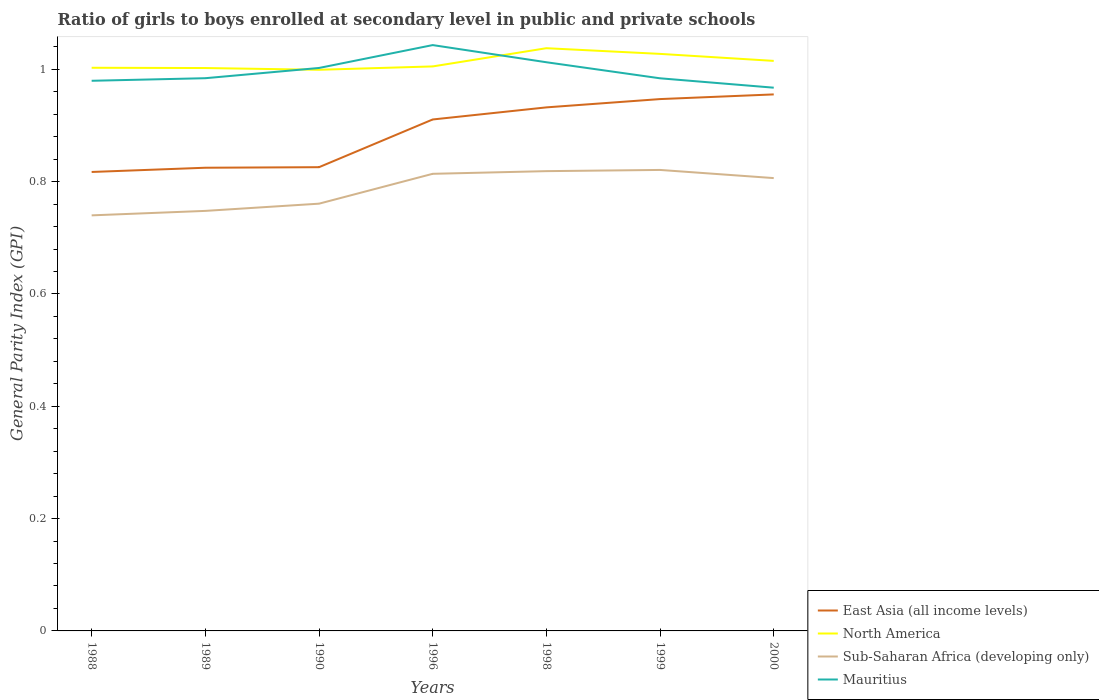How many different coloured lines are there?
Provide a short and direct response. 4. Does the line corresponding to Mauritius intersect with the line corresponding to East Asia (all income levels)?
Provide a succinct answer. No. Is the number of lines equal to the number of legend labels?
Your answer should be very brief. Yes. Across all years, what is the maximum general parity index in Sub-Saharan Africa (developing only)?
Your response must be concise. 0.74. In which year was the general parity index in North America maximum?
Ensure brevity in your answer.  1990. What is the total general parity index in East Asia (all income levels) in the graph?
Make the answer very short. -0.09. What is the difference between the highest and the second highest general parity index in Sub-Saharan Africa (developing only)?
Give a very brief answer. 0.08. What is the difference between the highest and the lowest general parity index in Mauritius?
Keep it short and to the point. 3. Is the general parity index in Sub-Saharan Africa (developing only) strictly greater than the general parity index in Mauritius over the years?
Provide a succinct answer. Yes. How many lines are there?
Your answer should be very brief. 4. What is the difference between two consecutive major ticks on the Y-axis?
Your answer should be compact. 0.2. Does the graph contain any zero values?
Offer a terse response. No. Does the graph contain grids?
Your response must be concise. No. Where does the legend appear in the graph?
Your answer should be compact. Bottom right. How many legend labels are there?
Ensure brevity in your answer.  4. What is the title of the graph?
Your answer should be compact. Ratio of girls to boys enrolled at secondary level in public and private schools. What is the label or title of the Y-axis?
Provide a succinct answer. General Parity Index (GPI). What is the General Parity Index (GPI) in East Asia (all income levels) in 1988?
Offer a terse response. 0.82. What is the General Parity Index (GPI) in North America in 1988?
Offer a terse response. 1. What is the General Parity Index (GPI) of Sub-Saharan Africa (developing only) in 1988?
Give a very brief answer. 0.74. What is the General Parity Index (GPI) of Mauritius in 1988?
Your answer should be very brief. 0.98. What is the General Parity Index (GPI) in East Asia (all income levels) in 1989?
Offer a terse response. 0.82. What is the General Parity Index (GPI) of North America in 1989?
Offer a terse response. 1. What is the General Parity Index (GPI) in Sub-Saharan Africa (developing only) in 1989?
Your answer should be very brief. 0.75. What is the General Parity Index (GPI) of Mauritius in 1989?
Provide a short and direct response. 0.98. What is the General Parity Index (GPI) in East Asia (all income levels) in 1990?
Provide a short and direct response. 0.83. What is the General Parity Index (GPI) of North America in 1990?
Offer a very short reply. 1. What is the General Parity Index (GPI) of Sub-Saharan Africa (developing only) in 1990?
Give a very brief answer. 0.76. What is the General Parity Index (GPI) in Mauritius in 1990?
Make the answer very short. 1. What is the General Parity Index (GPI) in East Asia (all income levels) in 1996?
Ensure brevity in your answer.  0.91. What is the General Parity Index (GPI) of North America in 1996?
Provide a short and direct response. 1.01. What is the General Parity Index (GPI) of Sub-Saharan Africa (developing only) in 1996?
Make the answer very short. 0.81. What is the General Parity Index (GPI) of Mauritius in 1996?
Keep it short and to the point. 1.04. What is the General Parity Index (GPI) in East Asia (all income levels) in 1998?
Keep it short and to the point. 0.93. What is the General Parity Index (GPI) in North America in 1998?
Your answer should be compact. 1.04. What is the General Parity Index (GPI) in Sub-Saharan Africa (developing only) in 1998?
Ensure brevity in your answer.  0.82. What is the General Parity Index (GPI) in Mauritius in 1998?
Your answer should be compact. 1.01. What is the General Parity Index (GPI) in East Asia (all income levels) in 1999?
Ensure brevity in your answer.  0.95. What is the General Parity Index (GPI) of North America in 1999?
Your response must be concise. 1.03. What is the General Parity Index (GPI) of Sub-Saharan Africa (developing only) in 1999?
Your answer should be compact. 0.82. What is the General Parity Index (GPI) in Mauritius in 1999?
Keep it short and to the point. 0.98. What is the General Parity Index (GPI) in East Asia (all income levels) in 2000?
Offer a terse response. 0.96. What is the General Parity Index (GPI) in North America in 2000?
Make the answer very short. 1.02. What is the General Parity Index (GPI) in Sub-Saharan Africa (developing only) in 2000?
Make the answer very short. 0.81. What is the General Parity Index (GPI) in Mauritius in 2000?
Offer a very short reply. 0.97. Across all years, what is the maximum General Parity Index (GPI) of East Asia (all income levels)?
Keep it short and to the point. 0.96. Across all years, what is the maximum General Parity Index (GPI) of North America?
Your response must be concise. 1.04. Across all years, what is the maximum General Parity Index (GPI) in Sub-Saharan Africa (developing only)?
Keep it short and to the point. 0.82. Across all years, what is the maximum General Parity Index (GPI) in Mauritius?
Keep it short and to the point. 1.04. Across all years, what is the minimum General Parity Index (GPI) of East Asia (all income levels)?
Your answer should be very brief. 0.82. Across all years, what is the minimum General Parity Index (GPI) in North America?
Provide a succinct answer. 1. Across all years, what is the minimum General Parity Index (GPI) in Sub-Saharan Africa (developing only)?
Your answer should be very brief. 0.74. Across all years, what is the minimum General Parity Index (GPI) in Mauritius?
Make the answer very short. 0.97. What is the total General Parity Index (GPI) of East Asia (all income levels) in the graph?
Offer a very short reply. 6.21. What is the total General Parity Index (GPI) of North America in the graph?
Your answer should be compact. 7.09. What is the total General Parity Index (GPI) of Sub-Saharan Africa (developing only) in the graph?
Your answer should be very brief. 5.51. What is the total General Parity Index (GPI) in Mauritius in the graph?
Offer a very short reply. 6.97. What is the difference between the General Parity Index (GPI) in East Asia (all income levels) in 1988 and that in 1989?
Keep it short and to the point. -0.01. What is the difference between the General Parity Index (GPI) in Sub-Saharan Africa (developing only) in 1988 and that in 1989?
Offer a very short reply. -0.01. What is the difference between the General Parity Index (GPI) in Mauritius in 1988 and that in 1989?
Make the answer very short. -0. What is the difference between the General Parity Index (GPI) in East Asia (all income levels) in 1988 and that in 1990?
Your response must be concise. -0.01. What is the difference between the General Parity Index (GPI) of North America in 1988 and that in 1990?
Give a very brief answer. 0. What is the difference between the General Parity Index (GPI) in Sub-Saharan Africa (developing only) in 1988 and that in 1990?
Keep it short and to the point. -0.02. What is the difference between the General Parity Index (GPI) in Mauritius in 1988 and that in 1990?
Provide a short and direct response. -0.02. What is the difference between the General Parity Index (GPI) of East Asia (all income levels) in 1988 and that in 1996?
Keep it short and to the point. -0.09. What is the difference between the General Parity Index (GPI) in North America in 1988 and that in 1996?
Keep it short and to the point. -0. What is the difference between the General Parity Index (GPI) of Sub-Saharan Africa (developing only) in 1988 and that in 1996?
Give a very brief answer. -0.07. What is the difference between the General Parity Index (GPI) of Mauritius in 1988 and that in 1996?
Give a very brief answer. -0.06. What is the difference between the General Parity Index (GPI) of East Asia (all income levels) in 1988 and that in 1998?
Your answer should be very brief. -0.12. What is the difference between the General Parity Index (GPI) of North America in 1988 and that in 1998?
Provide a short and direct response. -0.03. What is the difference between the General Parity Index (GPI) in Sub-Saharan Africa (developing only) in 1988 and that in 1998?
Provide a succinct answer. -0.08. What is the difference between the General Parity Index (GPI) in Mauritius in 1988 and that in 1998?
Ensure brevity in your answer.  -0.03. What is the difference between the General Parity Index (GPI) in East Asia (all income levels) in 1988 and that in 1999?
Offer a very short reply. -0.13. What is the difference between the General Parity Index (GPI) of North America in 1988 and that in 1999?
Your answer should be very brief. -0.02. What is the difference between the General Parity Index (GPI) of Sub-Saharan Africa (developing only) in 1988 and that in 1999?
Your response must be concise. -0.08. What is the difference between the General Parity Index (GPI) in Mauritius in 1988 and that in 1999?
Make the answer very short. -0. What is the difference between the General Parity Index (GPI) in East Asia (all income levels) in 1988 and that in 2000?
Offer a terse response. -0.14. What is the difference between the General Parity Index (GPI) in North America in 1988 and that in 2000?
Offer a very short reply. -0.01. What is the difference between the General Parity Index (GPI) of Sub-Saharan Africa (developing only) in 1988 and that in 2000?
Your answer should be compact. -0.07. What is the difference between the General Parity Index (GPI) of Mauritius in 1988 and that in 2000?
Offer a very short reply. 0.01. What is the difference between the General Parity Index (GPI) of East Asia (all income levels) in 1989 and that in 1990?
Ensure brevity in your answer.  -0. What is the difference between the General Parity Index (GPI) of North America in 1989 and that in 1990?
Provide a short and direct response. 0. What is the difference between the General Parity Index (GPI) of Sub-Saharan Africa (developing only) in 1989 and that in 1990?
Keep it short and to the point. -0.01. What is the difference between the General Parity Index (GPI) of Mauritius in 1989 and that in 1990?
Offer a terse response. -0.02. What is the difference between the General Parity Index (GPI) in East Asia (all income levels) in 1989 and that in 1996?
Provide a short and direct response. -0.09. What is the difference between the General Parity Index (GPI) of North America in 1989 and that in 1996?
Ensure brevity in your answer.  -0. What is the difference between the General Parity Index (GPI) in Sub-Saharan Africa (developing only) in 1989 and that in 1996?
Make the answer very short. -0.07. What is the difference between the General Parity Index (GPI) in Mauritius in 1989 and that in 1996?
Provide a short and direct response. -0.06. What is the difference between the General Parity Index (GPI) in East Asia (all income levels) in 1989 and that in 1998?
Your answer should be compact. -0.11. What is the difference between the General Parity Index (GPI) in North America in 1989 and that in 1998?
Ensure brevity in your answer.  -0.04. What is the difference between the General Parity Index (GPI) in Sub-Saharan Africa (developing only) in 1989 and that in 1998?
Offer a terse response. -0.07. What is the difference between the General Parity Index (GPI) of Mauritius in 1989 and that in 1998?
Your response must be concise. -0.03. What is the difference between the General Parity Index (GPI) of East Asia (all income levels) in 1989 and that in 1999?
Your answer should be compact. -0.12. What is the difference between the General Parity Index (GPI) in North America in 1989 and that in 1999?
Your response must be concise. -0.03. What is the difference between the General Parity Index (GPI) in Sub-Saharan Africa (developing only) in 1989 and that in 1999?
Keep it short and to the point. -0.07. What is the difference between the General Parity Index (GPI) of East Asia (all income levels) in 1989 and that in 2000?
Provide a short and direct response. -0.13. What is the difference between the General Parity Index (GPI) in North America in 1989 and that in 2000?
Keep it short and to the point. -0.01. What is the difference between the General Parity Index (GPI) of Sub-Saharan Africa (developing only) in 1989 and that in 2000?
Your response must be concise. -0.06. What is the difference between the General Parity Index (GPI) of Mauritius in 1989 and that in 2000?
Provide a short and direct response. 0.02. What is the difference between the General Parity Index (GPI) in East Asia (all income levels) in 1990 and that in 1996?
Keep it short and to the point. -0.09. What is the difference between the General Parity Index (GPI) of North America in 1990 and that in 1996?
Offer a very short reply. -0.01. What is the difference between the General Parity Index (GPI) of Sub-Saharan Africa (developing only) in 1990 and that in 1996?
Ensure brevity in your answer.  -0.05. What is the difference between the General Parity Index (GPI) of Mauritius in 1990 and that in 1996?
Offer a very short reply. -0.04. What is the difference between the General Parity Index (GPI) in East Asia (all income levels) in 1990 and that in 1998?
Ensure brevity in your answer.  -0.11. What is the difference between the General Parity Index (GPI) in North America in 1990 and that in 1998?
Offer a very short reply. -0.04. What is the difference between the General Parity Index (GPI) of Sub-Saharan Africa (developing only) in 1990 and that in 1998?
Provide a succinct answer. -0.06. What is the difference between the General Parity Index (GPI) in Mauritius in 1990 and that in 1998?
Make the answer very short. -0.01. What is the difference between the General Parity Index (GPI) in East Asia (all income levels) in 1990 and that in 1999?
Make the answer very short. -0.12. What is the difference between the General Parity Index (GPI) of North America in 1990 and that in 1999?
Offer a terse response. -0.03. What is the difference between the General Parity Index (GPI) of Sub-Saharan Africa (developing only) in 1990 and that in 1999?
Offer a very short reply. -0.06. What is the difference between the General Parity Index (GPI) in Mauritius in 1990 and that in 1999?
Provide a short and direct response. 0.02. What is the difference between the General Parity Index (GPI) in East Asia (all income levels) in 1990 and that in 2000?
Your answer should be compact. -0.13. What is the difference between the General Parity Index (GPI) of North America in 1990 and that in 2000?
Ensure brevity in your answer.  -0.02. What is the difference between the General Parity Index (GPI) in Sub-Saharan Africa (developing only) in 1990 and that in 2000?
Ensure brevity in your answer.  -0.05. What is the difference between the General Parity Index (GPI) of Mauritius in 1990 and that in 2000?
Keep it short and to the point. 0.04. What is the difference between the General Parity Index (GPI) of East Asia (all income levels) in 1996 and that in 1998?
Keep it short and to the point. -0.02. What is the difference between the General Parity Index (GPI) of North America in 1996 and that in 1998?
Ensure brevity in your answer.  -0.03. What is the difference between the General Parity Index (GPI) in Sub-Saharan Africa (developing only) in 1996 and that in 1998?
Your answer should be very brief. -0. What is the difference between the General Parity Index (GPI) of Mauritius in 1996 and that in 1998?
Provide a succinct answer. 0.03. What is the difference between the General Parity Index (GPI) in East Asia (all income levels) in 1996 and that in 1999?
Your answer should be compact. -0.04. What is the difference between the General Parity Index (GPI) of North America in 1996 and that in 1999?
Ensure brevity in your answer.  -0.02. What is the difference between the General Parity Index (GPI) in Sub-Saharan Africa (developing only) in 1996 and that in 1999?
Provide a short and direct response. -0.01. What is the difference between the General Parity Index (GPI) of Mauritius in 1996 and that in 1999?
Your answer should be very brief. 0.06. What is the difference between the General Parity Index (GPI) of East Asia (all income levels) in 1996 and that in 2000?
Make the answer very short. -0.04. What is the difference between the General Parity Index (GPI) in North America in 1996 and that in 2000?
Make the answer very short. -0.01. What is the difference between the General Parity Index (GPI) of Sub-Saharan Africa (developing only) in 1996 and that in 2000?
Give a very brief answer. 0.01. What is the difference between the General Parity Index (GPI) in Mauritius in 1996 and that in 2000?
Ensure brevity in your answer.  0.08. What is the difference between the General Parity Index (GPI) in East Asia (all income levels) in 1998 and that in 1999?
Your answer should be compact. -0.01. What is the difference between the General Parity Index (GPI) in North America in 1998 and that in 1999?
Your response must be concise. 0.01. What is the difference between the General Parity Index (GPI) of Sub-Saharan Africa (developing only) in 1998 and that in 1999?
Your response must be concise. -0. What is the difference between the General Parity Index (GPI) of Mauritius in 1998 and that in 1999?
Your answer should be compact. 0.03. What is the difference between the General Parity Index (GPI) of East Asia (all income levels) in 1998 and that in 2000?
Make the answer very short. -0.02. What is the difference between the General Parity Index (GPI) of North America in 1998 and that in 2000?
Keep it short and to the point. 0.02. What is the difference between the General Parity Index (GPI) of Sub-Saharan Africa (developing only) in 1998 and that in 2000?
Give a very brief answer. 0.01. What is the difference between the General Parity Index (GPI) of Mauritius in 1998 and that in 2000?
Offer a very short reply. 0.05. What is the difference between the General Parity Index (GPI) in East Asia (all income levels) in 1999 and that in 2000?
Your answer should be very brief. -0.01. What is the difference between the General Parity Index (GPI) of North America in 1999 and that in 2000?
Give a very brief answer. 0.01. What is the difference between the General Parity Index (GPI) of Sub-Saharan Africa (developing only) in 1999 and that in 2000?
Ensure brevity in your answer.  0.01. What is the difference between the General Parity Index (GPI) of Mauritius in 1999 and that in 2000?
Ensure brevity in your answer.  0.02. What is the difference between the General Parity Index (GPI) in East Asia (all income levels) in 1988 and the General Parity Index (GPI) in North America in 1989?
Keep it short and to the point. -0.19. What is the difference between the General Parity Index (GPI) of East Asia (all income levels) in 1988 and the General Parity Index (GPI) of Sub-Saharan Africa (developing only) in 1989?
Keep it short and to the point. 0.07. What is the difference between the General Parity Index (GPI) in East Asia (all income levels) in 1988 and the General Parity Index (GPI) in Mauritius in 1989?
Provide a short and direct response. -0.17. What is the difference between the General Parity Index (GPI) in North America in 1988 and the General Parity Index (GPI) in Sub-Saharan Africa (developing only) in 1989?
Provide a succinct answer. 0.25. What is the difference between the General Parity Index (GPI) in North America in 1988 and the General Parity Index (GPI) in Mauritius in 1989?
Your response must be concise. 0.02. What is the difference between the General Parity Index (GPI) of Sub-Saharan Africa (developing only) in 1988 and the General Parity Index (GPI) of Mauritius in 1989?
Keep it short and to the point. -0.24. What is the difference between the General Parity Index (GPI) in East Asia (all income levels) in 1988 and the General Parity Index (GPI) in North America in 1990?
Make the answer very short. -0.18. What is the difference between the General Parity Index (GPI) of East Asia (all income levels) in 1988 and the General Parity Index (GPI) of Sub-Saharan Africa (developing only) in 1990?
Provide a succinct answer. 0.06. What is the difference between the General Parity Index (GPI) of East Asia (all income levels) in 1988 and the General Parity Index (GPI) of Mauritius in 1990?
Keep it short and to the point. -0.19. What is the difference between the General Parity Index (GPI) of North America in 1988 and the General Parity Index (GPI) of Sub-Saharan Africa (developing only) in 1990?
Provide a succinct answer. 0.24. What is the difference between the General Parity Index (GPI) of Sub-Saharan Africa (developing only) in 1988 and the General Parity Index (GPI) of Mauritius in 1990?
Keep it short and to the point. -0.26. What is the difference between the General Parity Index (GPI) of East Asia (all income levels) in 1988 and the General Parity Index (GPI) of North America in 1996?
Give a very brief answer. -0.19. What is the difference between the General Parity Index (GPI) of East Asia (all income levels) in 1988 and the General Parity Index (GPI) of Sub-Saharan Africa (developing only) in 1996?
Your response must be concise. 0. What is the difference between the General Parity Index (GPI) of East Asia (all income levels) in 1988 and the General Parity Index (GPI) of Mauritius in 1996?
Your answer should be very brief. -0.23. What is the difference between the General Parity Index (GPI) in North America in 1988 and the General Parity Index (GPI) in Sub-Saharan Africa (developing only) in 1996?
Your response must be concise. 0.19. What is the difference between the General Parity Index (GPI) of North America in 1988 and the General Parity Index (GPI) of Mauritius in 1996?
Ensure brevity in your answer.  -0.04. What is the difference between the General Parity Index (GPI) of Sub-Saharan Africa (developing only) in 1988 and the General Parity Index (GPI) of Mauritius in 1996?
Your answer should be compact. -0.3. What is the difference between the General Parity Index (GPI) in East Asia (all income levels) in 1988 and the General Parity Index (GPI) in North America in 1998?
Your answer should be very brief. -0.22. What is the difference between the General Parity Index (GPI) in East Asia (all income levels) in 1988 and the General Parity Index (GPI) in Sub-Saharan Africa (developing only) in 1998?
Provide a short and direct response. -0. What is the difference between the General Parity Index (GPI) of East Asia (all income levels) in 1988 and the General Parity Index (GPI) of Mauritius in 1998?
Keep it short and to the point. -0.2. What is the difference between the General Parity Index (GPI) of North America in 1988 and the General Parity Index (GPI) of Sub-Saharan Africa (developing only) in 1998?
Provide a short and direct response. 0.18. What is the difference between the General Parity Index (GPI) in North America in 1988 and the General Parity Index (GPI) in Mauritius in 1998?
Offer a very short reply. -0.01. What is the difference between the General Parity Index (GPI) of Sub-Saharan Africa (developing only) in 1988 and the General Parity Index (GPI) of Mauritius in 1998?
Your answer should be compact. -0.27. What is the difference between the General Parity Index (GPI) of East Asia (all income levels) in 1988 and the General Parity Index (GPI) of North America in 1999?
Provide a succinct answer. -0.21. What is the difference between the General Parity Index (GPI) in East Asia (all income levels) in 1988 and the General Parity Index (GPI) in Sub-Saharan Africa (developing only) in 1999?
Provide a succinct answer. -0. What is the difference between the General Parity Index (GPI) of East Asia (all income levels) in 1988 and the General Parity Index (GPI) of Mauritius in 1999?
Give a very brief answer. -0.17. What is the difference between the General Parity Index (GPI) in North America in 1988 and the General Parity Index (GPI) in Sub-Saharan Africa (developing only) in 1999?
Ensure brevity in your answer.  0.18. What is the difference between the General Parity Index (GPI) in North America in 1988 and the General Parity Index (GPI) in Mauritius in 1999?
Offer a terse response. 0.02. What is the difference between the General Parity Index (GPI) in Sub-Saharan Africa (developing only) in 1988 and the General Parity Index (GPI) in Mauritius in 1999?
Ensure brevity in your answer.  -0.24. What is the difference between the General Parity Index (GPI) of East Asia (all income levels) in 1988 and the General Parity Index (GPI) of North America in 2000?
Give a very brief answer. -0.2. What is the difference between the General Parity Index (GPI) of East Asia (all income levels) in 1988 and the General Parity Index (GPI) of Sub-Saharan Africa (developing only) in 2000?
Your answer should be very brief. 0.01. What is the difference between the General Parity Index (GPI) of East Asia (all income levels) in 1988 and the General Parity Index (GPI) of Mauritius in 2000?
Offer a terse response. -0.15. What is the difference between the General Parity Index (GPI) of North America in 1988 and the General Parity Index (GPI) of Sub-Saharan Africa (developing only) in 2000?
Ensure brevity in your answer.  0.2. What is the difference between the General Parity Index (GPI) of North America in 1988 and the General Parity Index (GPI) of Mauritius in 2000?
Provide a short and direct response. 0.04. What is the difference between the General Parity Index (GPI) in Sub-Saharan Africa (developing only) in 1988 and the General Parity Index (GPI) in Mauritius in 2000?
Provide a succinct answer. -0.23. What is the difference between the General Parity Index (GPI) in East Asia (all income levels) in 1989 and the General Parity Index (GPI) in North America in 1990?
Ensure brevity in your answer.  -0.17. What is the difference between the General Parity Index (GPI) of East Asia (all income levels) in 1989 and the General Parity Index (GPI) of Sub-Saharan Africa (developing only) in 1990?
Provide a succinct answer. 0.06. What is the difference between the General Parity Index (GPI) of East Asia (all income levels) in 1989 and the General Parity Index (GPI) of Mauritius in 1990?
Keep it short and to the point. -0.18. What is the difference between the General Parity Index (GPI) in North America in 1989 and the General Parity Index (GPI) in Sub-Saharan Africa (developing only) in 1990?
Your response must be concise. 0.24. What is the difference between the General Parity Index (GPI) of North America in 1989 and the General Parity Index (GPI) of Mauritius in 1990?
Your response must be concise. -0. What is the difference between the General Parity Index (GPI) in Sub-Saharan Africa (developing only) in 1989 and the General Parity Index (GPI) in Mauritius in 1990?
Provide a succinct answer. -0.25. What is the difference between the General Parity Index (GPI) in East Asia (all income levels) in 1989 and the General Parity Index (GPI) in North America in 1996?
Your response must be concise. -0.18. What is the difference between the General Parity Index (GPI) in East Asia (all income levels) in 1989 and the General Parity Index (GPI) in Sub-Saharan Africa (developing only) in 1996?
Make the answer very short. 0.01. What is the difference between the General Parity Index (GPI) of East Asia (all income levels) in 1989 and the General Parity Index (GPI) of Mauritius in 1996?
Provide a succinct answer. -0.22. What is the difference between the General Parity Index (GPI) of North America in 1989 and the General Parity Index (GPI) of Sub-Saharan Africa (developing only) in 1996?
Your answer should be very brief. 0.19. What is the difference between the General Parity Index (GPI) in North America in 1989 and the General Parity Index (GPI) in Mauritius in 1996?
Your answer should be compact. -0.04. What is the difference between the General Parity Index (GPI) of Sub-Saharan Africa (developing only) in 1989 and the General Parity Index (GPI) of Mauritius in 1996?
Ensure brevity in your answer.  -0.3. What is the difference between the General Parity Index (GPI) in East Asia (all income levels) in 1989 and the General Parity Index (GPI) in North America in 1998?
Offer a very short reply. -0.21. What is the difference between the General Parity Index (GPI) of East Asia (all income levels) in 1989 and the General Parity Index (GPI) of Sub-Saharan Africa (developing only) in 1998?
Keep it short and to the point. 0.01. What is the difference between the General Parity Index (GPI) in East Asia (all income levels) in 1989 and the General Parity Index (GPI) in Mauritius in 1998?
Your answer should be very brief. -0.19. What is the difference between the General Parity Index (GPI) in North America in 1989 and the General Parity Index (GPI) in Sub-Saharan Africa (developing only) in 1998?
Your answer should be very brief. 0.18. What is the difference between the General Parity Index (GPI) of North America in 1989 and the General Parity Index (GPI) of Mauritius in 1998?
Your answer should be very brief. -0.01. What is the difference between the General Parity Index (GPI) of Sub-Saharan Africa (developing only) in 1989 and the General Parity Index (GPI) of Mauritius in 1998?
Your response must be concise. -0.26. What is the difference between the General Parity Index (GPI) in East Asia (all income levels) in 1989 and the General Parity Index (GPI) in North America in 1999?
Your response must be concise. -0.2. What is the difference between the General Parity Index (GPI) in East Asia (all income levels) in 1989 and the General Parity Index (GPI) in Sub-Saharan Africa (developing only) in 1999?
Your answer should be compact. 0. What is the difference between the General Parity Index (GPI) of East Asia (all income levels) in 1989 and the General Parity Index (GPI) of Mauritius in 1999?
Offer a terse response. -0.16. What is the difference between the General Parity Index (GPI) in North America in 1989 and the General Parity Index (GPI) in Sub-Saharan Africa (developing only) in 1999?
Your answer should be very brief. 0.18. What is the difference between the General Parity Index (GPI) of North America in 1989 and the General Parity Index (GPI) of Mauritius in 1999?
Provide a short and direct response. 0.02. What is the difference between the General Parity Index (GPI) in Sub-Saharan Africa (developing only) in 1989 and the General Parity Index (GPI) in Mauritius in 1999?
Make the answer very short. -0.24. What is the difference between the General Parity Index (GPI) in East Asia (all income levels) in 1989 and the General Parity Index (GPI) in North America in 2000?
Make the answer very short. -0.19. What is the difference between the General Parity Index (GPI) of East Asia (all income levels) in 1989 and the General Parity Index (GPI) of Sub-Saharan Africa (developing only) in 2000?
Your answer should be compact. 0.02. What is the difference between the General Parity Index (GPI) in East Asia (all income levels) in 1989 and the General Parity Index (GPI) in Mauritius in 2000?
Your answer should be very brief. -0.14. What is the difference between the General Parity Index (GPI) in North America in 1989 and the General Parity Index (GPI) in Sub-Saharan Africa (developing only) in 2000?
Provide a short and direct response. 0.2. What is the difference between the General Parity Index (GPI) in North America in 1989 and the General Parity Index (GPI) in Mauritius in 2000?
Your response must be concise. 0.04. What is the difference between the General Parity Index (GPI) in Sub-Saharan Africa (developing only) in 1989 and the General Parity Index (GPI) in Mauritius in 2000?
Make the answer very short. -0.22. What is the difference between the General Parity Index (GPI) of East Asia (all income levels) in 1990 and the General Parity Index (GPI) of North America in 1996?
Provide a succinct answer. -0.18. What is the difference between the General Parity Index (GPI) of East Asia (all income levels) in 1990 and the General Parity Index (GPI) of Sub-Saharan Africa (developing only) in 1996?
Offer a very short reply. 0.01. What is the difference between the General Parity Index (GPI) in East Asia (all income levels) in 1990 and the General Parity Index (GPI) in Mauritius in 1996?
Offer a very short reply. -0.22. What is the difference between the General Parity Index (GPI) in North America in 1990 and the General Parity Index (GPI) in Sub-Saharan Africa (developing only) in 1996?
Your answer should be compact. 0.19. What is the difference between the General Parity Index (GPI) of North America in 1990 and the General Parity Index (GPI) of Mauritius in 1996?
Provide a short and direct response. -0.04. What is the difference between the General Parity Index (GPI) of Sub-Saharan Africa (developing only) in 1990 and the General Parity Index (GPI) of Mauritius in 1996?
Offer a terse response. -0.28. What is the difference between the General Parity Index (GPI) of East Asia (all income levels) in 1990 and the General Parity Index (GPI) of North America in 1998?
Your answer should be very brief. -0.21. What is the difference between the General Parity Index (GPI) in East Asia (all income levels) in 1990 and the General Parity Index (GPI) in Sub-Saharan Africa (developing only) in 1998?
Your answer should be very brief. 0.01. What is the difference between the General Parity Index (GPI) of East Asia (all income levels) in 1990 and the General Parity Index (GPI) of Mauritius in 1998?
Provide a short and direct response. -0.19. What is the difference between the General Parity Index (GPI) of North America in 1990 and the General Parity Index (GPI) of Sub-Saharan Africa (developing only) in 1998?
Ensure brevity in your answer.  0.18. What is the difference between the General Parity Index (GPI) in North America in 1990 and the General Parity Index (GPI) in Mauritius in 1998?
Keep it short and to the point. -0.01. What is the difference between the General Parity Index (GPI) of Sub-Saharan Africa (developing only) in 1990 and the General Parity Index (GPI) of Mauritius in 1998?
Offer a very short reply. -0.25. What is the difference between the General Parity Index (GPI) in East Asia (all income levels) in 1990 and the General Parity Index (GPI) in North America in 1999?
Your response must be concise. -0.2. What is the difference between the General Parity Index (GPI) of East Asia (all income levels) in 1990 and the General Parity Index (GPI) of Sub-Saharan Africa (developing only) in 1999?
Keep it short and to the point. 0. What is the difference between the General Parity Index (GPI) in East Asia (all income levels) in 1990 and the General Parity Index (GPI) in Mauritius in 1999?
Give a very brief answer. -0.16. What is the difference between the General Parity Index (GPI) in North America in 1990 and the General Parity Index (GPI) in Sub-Saharan Africa (developing only) in 1999?
Provide a short and direct response. 0.18. What is the difference between the General Parity Index (GPI) in North America in 1990 and the General Parity Index (GPI) in Mauritius in 1999?
Ensure brevity in your answer.  0.02. What is the difference between the General Parity Index (GPI) in Sub-Saharan Africa (developing only) in 1990 and the General Parity Index (GPI) in Mauritius in 1999?
Your answer should be very brief. -0.22. What is the difference between the General Parity Index (GPI) in East Asia (all income levels) in 1990 and the General Parity Index (GPI) in North America in 2000?
Provide a succinct answer. -0.19. What is the difference between the General Parity Index (GPI) in East Asia (all income levels) in 1990 and the General Parity Index (GPI) in Sub-Saharan Africa (developing only) in 2000?
Your answer should be very brief. 0.02. What is the difference between the General Parity Index (GPI) in East Asia (all income levels) in 1990 and the General Parity Index (GPI) in Mauritius in 2000?
Ensure brevity in your answer.  -0.14. What is the difference between the General Parity Index (GPI) of North America in 1990 and the General Parity Index (GPI) of Sub-Saharan Africa (developing only) in 2000?
Offer a very short reply. 0.19. What is the difference between the General Parity Index (GPI) in North America in 1990 and the General Parity Index (GPI) in Mauritius in 2000?
Make the answer very short. 0.03. What is the difference between the General Parity Index (GPI) in Sub-Saharan Africa (developing only) in 1990 and the General Parity Index (GPI) in Mauritius in 2000?
Keep it short and to the point. -0.21. What is the difference between the General Parity Index (GPI) of East Asia (all income levels) in 1996 and the General Parity Index (GPI) of North America in 1998?
Ensure brevity in your answer.  -0.13. What is the difference between the General Parity Index (GPI) of East Asia (all income levels) in 1996 and the General Parity Index (GPI) of Sub-Saharan Africa (developing only) in 1998?
Make the answer very short. 0.09. What is the difference between the General Parity Index (GPI) in East Asia (all income levels) in 1996 and the General Parity Index (GPI) in Mauritius in 1998?
Your answer should be compact. -0.1. What is the difference between the General Parity Index (GPI) in North America in 1996 and the General Parity Index (GPI) in Sub-Saharan Africa (developing only) in 1998?
Provide a short and direct response. 0.19. What is the difference between the General Parity Index (GPI) in North America in 1996 and the General Parity Index (GPI) in Mauritius in 1998?
Make the answer very short. -0.01. What is the difference between the General Parity Index (GPI) in Sub-Saharan Africa (developing only) in 1996 and the General Parity Index (GPI) in Mauritius in 1998?
Your response must be concise. -0.2. What is the difference between the General Parity Index (GPI) of East Asia (all income levels) in 1996 and the General Parity Index (GPI) of North America in 1999?
Your response must be concise. -0.12. What is the difference between the General Parity Index (GPI) in East Asia (all income levels) in 1996 and the General Parity Index (GPI) in Sub-Saharan Africa (developing only) in 1999?
Your answer should be compact. 0.09. What is the difference between the General Parity Index (GPI) of East Asia (all income levels) in 1996 and the General Parity Index (GPI) of Mauritius in 1999?
Provide a succinct answer. -0.07. What is the difference between the General Parity Index (GPI) in North America in 1996 and the General Parity Index (GPI) in Sub-Saharan Africa (developing only) in 1999?
Give a very brief answer. 0.18. What is the difference between the General Parity Index (GPI) in North America in 1996 and the General Parity Index (GPI) in Mauritius in 1999?
Your answer should be very brief. 0.02. What is the difference between the General Parity Index (GPI) of Sub-Saharan Africa (developing only) in 1996 and the General Parity Index (GPI) of Mauritius in 1999?
Your response must be concise. -0.17. What is the difference between the General Parity Index (GPI) of East Asia (all income levels) in 1996 and the General Parity Index (GPI) of North America in 2000?
Ensure brevity in your answer.  -0.1. What is the difference between the General Parity Index (GPI) in East Asia (all income levels) in 1996 and the General Parity Index (GPI) in Sub-Saharan Africa (developing only) in 2000?
Provide a succinct answer. 0.1. What is the difference between the General Parity Index (GPI) in East Asia (all income levels) in 1996 and the General Parity Index (GPI) in Mauritius in 2000?
Your response must be concise. -0.06. What is the difference between the General Parity Index (GPI) of North America in 1996 and the General Parity Index (GPI) of Sub-Saharan Africa (developing only) in 2000?
Offer a very short reply. 0.2. What is the difference between the General Parity Index (GPI) in North America in 1996 and the General Parity Index (GPI) in Mauritius in 2000?
Your answer should be compact. 0.04. What is the difference between the General Parity Index (GPI) in Sub-Saharan Africa (developing only) in 1996 and the General Parity Index (GPI) in Mauritius in 2000?
Ensure brevity in your answer.  -0.15. What is the difference between the General Parity Index (GPI) of East Asia (all income levels) in 1998 and the General Parity Index (GPI) of North America in 1999?
Your response must be concise. -0.1. What is the difference between the General Parity Index (GPI) in East Asia (all income levels) in 1998 and the General Parity Index (GPI) in Sub-Saharan Africa (developing only) in 1999?
Your response must be concise. 0.11. What is the difference between the General Parity Index (GPI) of East Asia (all income levels) in 1998 and the General Parity Index (GPI) of Mauritius in 1999?
Offer a terse response. -0.05. What is the difference between the General Parity Index (GPI) of North America in 1998 and the General Parity Index (GPI) of Sub-Saharan Africa (developing only) in 1999?
Provide a succinct answer. 0.22. What is the difference between the General Parity Index (GPI) in North America in 1998 and the General Parity Index (GPI) in Mauritius in 1999?
Keep it short and to the point. 0.05. What is the difference between the General Parity Index (GPI) of Sub-Saharan Africa (developing only) in 1998 and the General Parity Index (GPI) of Mauritius in 1999?
Keep it short and to the point. -0.17. What is the difference between the General Parity Index (GPI) in East Asia (all income levels) in 1998 and the General Parity Index (GPI) in North America in 2000?
Provide a short and direct response. -0.08. What is the difference between the General Parity Index (GPI) in East Asia (all income levels) in 1998 and the General Parity Index (GPI) in Sub-Saharan Africa (developing only) in 2000?
Ensure brevity in your answer.  0.13. What is the difference between the General Parity Index (GPI) in East Asia (all income levels) in 1998 and the General Parity Index (GPI) in Mauritius in 2000?
Your response must be concise. -0.04. What is the difference between the General Parity Index (GPI) in North America in 1998 and the General Parity Index (GPI) in Sub-Saharan Africa (developing only) in 2000?
Your answer should be compact. 0.23. What is the difference between the General Parity Index (GPI) in North America in 1998 and the General Parity Index (GPI) in Mauritius in 2000?
Give a very brief answer. 0.07. What is the difference between the General Parity Index (GPI) in Sub-Saharan Africa (developing only) in 1998 and the General Parity Index (GPI) in Mauritius in 2000?
Your answer should be very brief. -0.15. What is the difference between the General Parity Index (GPI) of East Asia (all income levels) in 1999 and the General Parity Index (GPI) of North America in 2000?
Keep it short and to the point. -0.07. What is the difference between the General Parity Index (GPI) of East Asia (all income levels) in 1999 and the General Parity Index (GPI) of Sub-Saharan Africa (developing only) in 2000?
Ensure brevity in your answer.  0.14. What is the difference between the General Parity Index (GPI) of East Asia (all income levels) in 1999 and the General Parity Index (GPI) of Mauritius in 2000?
Provide a succinct answer. -0.02. What is the difference between the General Parity Index (GPI) in North America in 1999 and the General Parity Index (GPI) in Sub-Saharan Africa (developing only) in 2000?
Your answer should be very brief. 0.22. What is the difference between the General Parity Index (GPI) of North America in 1999 and the General Parity Index (GPI) of Mauritius in 2000?
Give a very brief answer. 0.06. What is the difference between the General Parity Index (GPI) of Sub-Saharan Africa (developing only) in 1999 and the General Parity Index (GPI) of Mauritius in 2000?
Keep it short and to the point. -0.15. What is the average General Parity Index (GPI) of East Asia (all income levels) per year?
Your answer should be very brief. 0.89. What is the average General Parity Index (GPI) in North America per year?
Your answer should be compact. 1.01. What is the average General Parity Index (GPI) of Sub-Saharan Africa (developing only) per year?
Provide a short and direct response. 0.79. What is the average General Parity Index (GPI) in Mauritius per year?
Ensure brevity in your answer.  1. In the year 1988, what is the difference between the General Parity Index (GPI) in East Asia (all income levels) and General Parity Index (GPI) in North America?
Offer a very short reply. -0.19. In the year 1988, what is the difference between the General Parity Index (GPI) of East Asia (all income levels) and General Parity Index (GPI) of Sub-Saharan Africa (developing only)?
Your answer should be very brief. 0.08. In the year 1988, what is the difference between the General Parity Index (GPI) of East Asia (all income levels) and General Parity Index (GPI) of Mauritius?
Provide a succinct answer. -0.16. In the year 1988, what is the difference between the General Parity Index (GPI) of North America and General Parity Index (GPI) of Sub-Saharan Africa (developing only)?
Provide a succinct answer. 0.26. In the year 1988, what is the difference between the General Parity Index (GPI) in North America and General Parity Index (GPI) in Mauritius?
Your answer should be very brief. 0.02. In the year 1988, what is the difference between the General Parity Index (GPI) of Sub-Saharan Africa (developing only) and General Parity Index (GPI) of Mauritius?
Give a very brief answer. -0.24. In the year 1989, what is the difference between the General Parity Index (GPI) of East Asia (all income levels) and General Parity Index (GPI) of North America?
Ensure brevity in your answer.  -0.18. In the year 1989, what is the difference between the General Parity Index (GPI) in East Asia (all income levels) and General Parity Index (GPI) in Sub-Saharan Africa (developing only)?
Provide a short and direct response. 0.08. In the year 1989, what is the difference between the General Parity Index (GPI) in East Asia (all income levels) and General Parity Index (GPI) in Mauritius?
Your response must be concise. -0.16. In the year 1989, what is the difference between the General Parity Index (GPI) of North America and General Parity Index (GPI) of Sub-Saharan Africa (developing only)?
Give a very brief answer. 0.25. In the year 1989, what is the difference between the General Parity Index (GPI) in North America and General Parity Index (GPI) in Mauritius?
Provide a short and direct response. 0.02. In the year 1989, what is the difference between the General Parity Index (GPI) in Sub-Saharan Africa (developing only) and General Parity Index (GPI) in Mauritius?
Your answer should be very brief. -0.24. In the year 1990, what is the difference between the General Parity Index (GPI) of East Asia (all income levels) and General Parity Index (GPI) of North America?
Ensure brevity in your answer.  -0.17. In the year 1990, what is the difference between the General Parity Index (GPI) in East Asia (all income levels) and General Parity Index (GPI) in Sub-Saharan Africa (developing only)?
Give a very brief answer. 0.07. In the year 1990, what is the difference between the General Parity Index (GPI) of East Asia (all income levels) and General Parity Index (GPI) of Mauritius?
Your answer should be compact. -0.18. In the year 1990, what is the difference between the General Parity Index (GPI) of North America and General Parity Index (GPI) of Sub-Saharan Africa (developing only)?
Offer a very short reply. 0.24. In the year 1990, what is the difference between the General Parity Index (GPI) of North America and General Parity Index (GPI) of Mauritius?
Your answer should be compact. -0. In the year 1990, what is the difference between the General Parity Index (GPI) in Sub-Saharan Africa (developing only) and General Parity Index (GPI) in Mauritius?
Your answer should be very brief. -0.24. In the year 1996, what is the difference between the General Parity Index (GPI) of East Asia (all income levels) and General Parity Index (GPI) of North America?
Provide a succinct answer. -0.09. In the year 1996, what is the difference between the General Parity Index (GPI) of East Asia (all income levels) and General Parity Index (GPI) of Sub-Saharan Africa (developing only)?
Your answer should be very brief. 0.1. In the year 1996, what is the difference between the General Parity Index (GPI) in East Asia (all income levels) and General Parity Index (GPI) in Mauritius?
Provide a short and direct response. -0.13. In the year 1996, what is the difference between the General Parity Index (GPI) of North America and General Parity Index (GPI) of Sub-Saharan Africa (developing only)?
Keep it short and to the point. 0.19. In the year 1996, what is the difference between the General Parity Index (GPI) in North America and General Parity Index (GPI) in Mauritius?
Ensure brevity in your answer.  -0.04. In the year 1996, what is the difference between the General Parity Index (GPI) in Sub-Saharan Africa (developing only) and General Parity Index (GPI) in Mauritius?
Ensure brevity in your answer.  -0.23. In the year 1998, what is the difference between the General Parity Index (GPI) of East Asia (all income levels) and General Parity Index (GPI) of North America?
Your answer should be very brief. -0.11. In the year 1998, what is the difference between the General Parity Index (GPI) of East Asia (all income levels) and General Parity Index (GPI) of Sub-Saharan Africa (developing only)?
Offer a terse response. 0.11. In the year 1998, what is the difference between the General Parity Index (GPI) in East Asia (all income levels) and General Parity Index (GPI) in Mauritius?
Make the answer very short. -0.08. In the year 1998, what is the difference between the General Parity Index (GPI) in North America and General Parity Index (GPI) in Sub-Saharan Africa (developing only)?
Your answer should be compact. 0.22. In the year 1998, what is the difference between the General Parity Index (GPI) of North America and General Parity Index (GPI) of Mauritius?
Your answer should be compact. 0.03. In the year 1998, what is the difference between the General Parity Index (GPI) in Sub-Saharan Africa (developing only) and General Parity Index (GPI) in Mauritius?
Your response must be concise. -0.19. In the year 1999, what is the difference between the General Parity Index (GPI) in East Asia (all income levels) and General Parity Index (GPI) in North America?
Ensure brevity in your answer.  -0.08. In the year 1999, what is the difference between the General Parity Index (GPI) of East Asia (all income levels) and General Parity Index (GPI) of Sub-Saharan Africa (developing only)?
Offer a terse response. 0.13. In the year 1999, what is the difference between the General Parity Index (GPI) in East Asia (all income levels) and General Parity Index (GPI) in Mauritius?
Make the answer very short. -0.04. In the year 1999, what is the difference between the General Parity Index (GPI) in North America and General Parity Index (GPI) in Sub-Saharan Africa (developing only)?
Ensure brevity in your answer.  0.21. In the year 1999, what is the difference between the General Parity Index (GPI) in North America and General Parity Index (GPI) in Mauritius?
Provide a short and direct response. 0.04. In the year 1999, what is the difference between the General Parity Index (GPI) in Sub-Saharan Africa (developing only) and General Parity Index (GPI) in Mauritius?
Provide a short and direct response. -0.16. In the year 2000, what is the difference between the General Parity Index (GPI) in East Asia (all income levels) and General Parity Index (GPI) in North America?
Your answer should be compact. -0.06. In the year 2000, what is the difference between the General Parity Index (GPI) of East Asia (all income levels) and General Parity Index (GPI) of Sub-Saharan Africa (developing only)?
Offer a very short reply. 0.15. In the year 2000, what is the difference between the General Parity Index (GPI) of East Asia (all income levels) and General Parity Index (GPI) of Mauritius?
Provide a succinct answer. -0.01. In the year 2000, what is the difference between the General Parity Index (GPI) in North America and General Parity Index (GPI) in Sub-Saharan Africa (developing only)?
Your answer should be compact. 0.21. In the year 2000, what is the difference between the General Parity Index (GPI) of North America and General Parity Index (GPI) of Mauritius?
Your response must be concise. 0.05. In the year 2000, what is the difference between the General Parity Index (GPI) in Sub-Saharan Africa (developing only) and General Parity Index (GPI) in Mauritius?
Your answer should be very brief. -0.16. What is the ratio of the General Parity Index (GPI) in East Asia (all income levels) in 1988 to that in 1989?
Your response must be concise. 0.99. What is the ratio of the General Parity Index (GPI) in Mauritius in 1988 to that in 1989?
Provide a succinct answer. 1. What is the ratio of the General Parity Index (GPI) of North America in 1988 to that in 1990?
Keep it short and to the point. 1. What is the ratio of the General Parity Index (GPI) of Sub-Saharan Africa (developing only) in 1988 to that in 1990?
Your answer should be compact. 0.97. What is the ratio of the General Parity Index (GPI) in Mauritius in 1988 to that in 1990?
Offer a very short reply. 0.98. What is the ratio of the General Parity Index (GPI) of East Asia (all income levels) in 1988 to that in 1996?
Your response must be concise. 0.9. What is the ratio of the General Parity Index (GPI) of North America in 1988 to that in 1996?
Provide a short and direct response. 1. What is the ratio of the General Parity Index (GPI) of Sub-Saharan Africa (developing only) in 1988 to that in 1996?
Give a very brief answer. 0.91. What is the ratio of the General Parity Index (GPI) of Mauritius in 1988 to that in 1996?
Give a very brief answer. 0.94. What is the ratio of the General Parity Index (GPI) in East Asia (all income levels) in 1988 to that in 1998?
Make the answer very short. 0.88. What is the ratio of the General Parity Index (GPI) in North America in 1988 to that in 1998?
Provide a short and direct response. 0.97. What is the ratio of the General Parity Index (GPI) in Sub-Saharan Africa (developing only) in 1988 to that in 1998?
Provide a succinct answer. 0.9. What is the ratio of the General Parity Index (GPI) of Mauritius in 1988 to that in 1998?
Your answer should be very brief. 0.97. What is the ratio of the General Parity Index (GPI) in East Asia (all income levels) in 1988 to that in 1999?
Provide a short and direct response. 0.86. What is the ratio of the General Parity Index (GPI) in North America in 1988 to that in 1999?
Your response must be concise. 0.98. What is the ratio of the General Parity Index (GPI) in Sub-Saharan Africa (developing only) in 1988 to that in 1999?
Give a very brief answer. 0.9. What is the ratio of the General Parity Index (GPI) of Mauritius in 1988 to that in 1999?
Your answer should be very brief. 1. What is the ratio of the General Parity Index (GPI) in East Asia (all income levels) in 1988 to that in 2000?
Your response must be concise. 0.86. What is the ratio of the General Parity Index (GPI) of North America in 1988 to that in 2000?
Your answer should be compact. 0.99. What is the ratio of the General Parity Index (GPI) of Sub-Saharan Africa (developing only) in 1988 to that in 2000?
Keep it short and to the point. 0.92. What is the ratio of the General Parity Index (GPI) of Mauritius in 1988 to that in 2000?
Your answer should be very brief. 1.01. What is the ratio of the General Parity Index (GPI) in North America in 1989 to that in 1990?
Your response must be concise. 1. What is the ratio of the General Parity Index (GPI) of Sub-Saharan Africa (developing only) in 1989 to that in 1990?
Make the answer very short. 0.98. What is the ratio of the General Parity Index (GPI) in Mauritius in 1989 to that in 1990?
Provide a succinct answer. 0.98. What is the ratio of the General Parity Index (GPI) of East Asia (all income levels) in 1989 to that in 1996?
Make the answer very short. 0.91. What is the ratio of the General Parity Index (GPI) in Sub-Saharan Africa (developing only) in 1989 to that in 1996?
Your answer should be compact. 0.92. What is the ratio of the General Parity Index (GPI) of Mauritius in 1989 to that in 1996?
Ensure brevity in your answer.  0.94. What is the ratio of the General Parity Index (GPI) in East Asia (all income levels) in 1989 to that in 1998?
Keep it short and to the point. 0.88. What is the ratio of the General Parity Index (GPI) of Sub-Saharan Africa (developing only) in 1989 to that in 1998?
Your answer should be very brief. 0.91. What is the ratio of the General Parity Index (GPI) in Mauritius in 1989 to that in 1998?
Your response must be concise. 0.97. What is the ratio of the General Parity Index (GPI) in East Asia (all income levels) in 1989 to that in 1999?
Provide a short and direct response. 0.87. What is the ratio of the General Parity Index (GPI) of North America in 1989 to that in 1999?
Your answer should be compact. 0.98. What is the ratio of the General Parity Index (GPI) of Sub-Saharan Africa (developing only) in 1989 to that in 1999?
Your answer should be compact. 0.91. What is the ratio of the General Parity Index (GPI) in East Asia (all income levels) in 1989 to that in 2000?
Provide a short and direct response. 0.86. What is the ratio of the General Parity Index (GPI) in North America in 1989 to that in 2000?
Keep it short and to the point. 0.99. What is the ratio of the General Parity Index (GPI) in Sub-Saharan Africa (developing only) in 1989 to that in 2000?
Ensure brevity in your answer.  0.93. What is the ratio of the General Parity Index (GPI) of Mauritius in 1989 to that in 2000?
Offer a terse response. 1.02. What is the ratio of the General Parity Index (GPI) in East Asia (all income levels) in 1990 to that in 1996?
Offer a terse response. 0.91. What is the ratio of the General Parity Index (GPI) of Sub-Saharan Africa (developing only) in 1990 to that in 1996?
Make the answer very short. 0.93. What is the ratio of the General Parity Index (GPI) in Mauritius in 1990 to that in 1996?
Offer a terse response. 0.96. What is the ratio of the General Parity Index (GPI) in East Asia (all income levels) in 1990 to that in 1998?
Provide a succinct answer. 0.89. What is the ratio of the General Parity Index (GPI) of Sub-Saharan Africa (developing only) in 1990 to that in 1998?
Offer a terse response. 0.93. What is the ratio of the General Parity Index (GPI) of Mauritius in 1990 to that in 1998?
Offer a very short reply. 0.99. What is the ratio of the General Parity Index (GPI) in East Asia (all income levels) in 1990 to that in 1999?
Offer a very short reply. 0.87. What is the ratio of the General Parity Index (GPI) in North America in 1990 to that in 1999?
Make the answer very short. 0.97. What is the ratio of the General Parity Index (GPI) of Sub-Saharan Africa (developing only) in 1990 to that in 1999?
Offer a very short reply. 0.93. What is the ratio of the General Parity Index (GPI) in Mauritius in 1990 to that in 1999?
Your response must be concise. 1.02. What is the ratio of the General Parity Index (GPI) of East Asia (all income levels) in 1990 to that in 2000?
Your answer should be compact. 0.86. What is the ratio of the General Parity Index (GPI) in North America in 1990 to that in 2000?
Give a very brief answer. 0.98. What is the ratio of the General Parity Index (GPI) of Sub-Saharan Africa (developing only) in 1990 to that in 2000?
Provide a succinct answer. 0.94. What is the ratio of the General Parity Index (GPI) in Mauritius in 1990 to that in 2000?
Provide a succinct answer. 1.04. What is the ratio of the General Parity Index (GPI) of East Asia (all income levels) in 1996 to that in 1998?
Your response must be concise. 0.98. What is the ratio of the General Parity Index (GPI) in North America in 1996 to that in 1998?
Ensure brevity in your answer.  0.97. What is the ratio of the General Parity Index (GPI) in Sub-Saharan Africa (developing only) in 1996 to that in 1998?
Provide a short and direct response. 0.99. What is the ratio of the General Parity Index (GPI) of Mauritius in 1996 to that in 1998?
Make the answer very short. 1.03. What is the ratio of the General Parity Index (GPI) in East Asia (all income levels) in 1996 to that in 1999?
Provide a short and direct response. 0.96. What is the ratio of the General Parity Index (GPI) of North America in 1996 to that in 1999?
Your answer should be compact. 0.98. What is the ratio of the General Parity Index (GPI) in Sub-Saharan Africa (developing only) in 1996 to that in 1999?
Your response must be concise. 0.99. What is the ratio of the General Parity Index (GPI) of Mauritius in 1996 to that in 1999?
Provide a short and direct response. 1.06. What is the ratio of the General Parity Index (GPI) in East Asia (all income levels) in 1996 to that in 2000?
Offer a terse response. 0.95. What is the ratio of the General Parity Index (GPI) of North America in 1996 to that in 2000?
Offer a very short reply. 0.99. What is the ratio of the General Parity Index (GPI) in Sub-Saharan Africa (developing only) in 1996 to that in 2000?
Offer a terse response. 1.01. What is the ratio of the General Parity Index (GPI) of Mauritius in 1996 to that in 2000?
Ensure brevity in your answer.  1.08. What is the ratio of the General Parity Index (GPI) of East Asia (all income levels) in 1998 to that in 1999?
Your response must be concise. 0.98. What is the ratio of the General Parity Index (GPI) of North America in 1998 to that in 1999?
Give a very brief answer. 1.01. What is the ratio of the General Parity Index (GPI) in Sub-Saharan Africa (developing only) in 1998 to that in 1999?
Your answer should be compact. 1. What is the ratio of the General Parity Index (GPI) in Mauritius in 1998 to that in 1999?
Your answer should be very brief. 1.03. What is the ratio of the General Parity Index (GPI) of East Asia (all income levels) in 1998 to that in 2000?
Your answer should be compact. 0.98. What is the ratio of the General Parity Index (GPI) in North America in 1998 to that in 2000?
Your answer should be compact. 1.02. What is the ratio of the General Parity Index (GPI) of Sub-Saharan Africa (developing only) in 1998 to that in 2000?
Offer a very short reply. 1.02. What is the ratio of the General Parity Index (GPI) of Mauritius in 1998 to that in 2000?
Your answer should be compact. 1.05. What is the ratio of the General Parity Index (GPI) in East Asia (all income levels) in 1999 to that in 2000?
Provide a succinct answer. 0.99. What is the ratio of the General Parity Index (GPI) of North America in 1999 to that in 2000?
Ensure brevity in your answer.  1.01. What is the ratio of the General Parity Index (GPI) in Sub-Saharan Africa (developing only) in 1999 to that in 2000?
Make the answer very short. 1.02. What is the ratio of the General Parity Index (GPI) in Mauritius in 1999 to that in 2000?
Keep it short and to the point. 1.02. What is the difference between the highest and the second highest General Parity Index (GPI) in East Asia (all income levels)?
Provide a short and direct response. 0.01. What is the difference between the highest and the second highest General Parity Index (GPI) in North America?
Provide a succinct answer. 0.01. What is the difference between the highest and the second highest General Parity Index (GPI) of Sub-Saharan Africa (developing only)?
Provide a short and direct response. 0. What is the difference between the highest and the second highest General Parity Index (GPI) in Mauritius?
Your response must be concise. 0.03. What is the difference between the highest and the lowest General Parity Index (GPI) in East Asia (all income levels)?
Offer a very short reply. 0.14. What is the difference between the highest and the lowest General Parity Index (GPI) of North America?
Give a very brief answer. 0.04. What is the difference between the highest and the lowest General Parity Index (GPI) in Sub-Saharan Africa (developing only)?
Offer a very short reply. 0.08. What is the difference between the highest and the lowest General Parity Index (GPI) in Mauritius?
Provide a short and direct response. 0.08. 